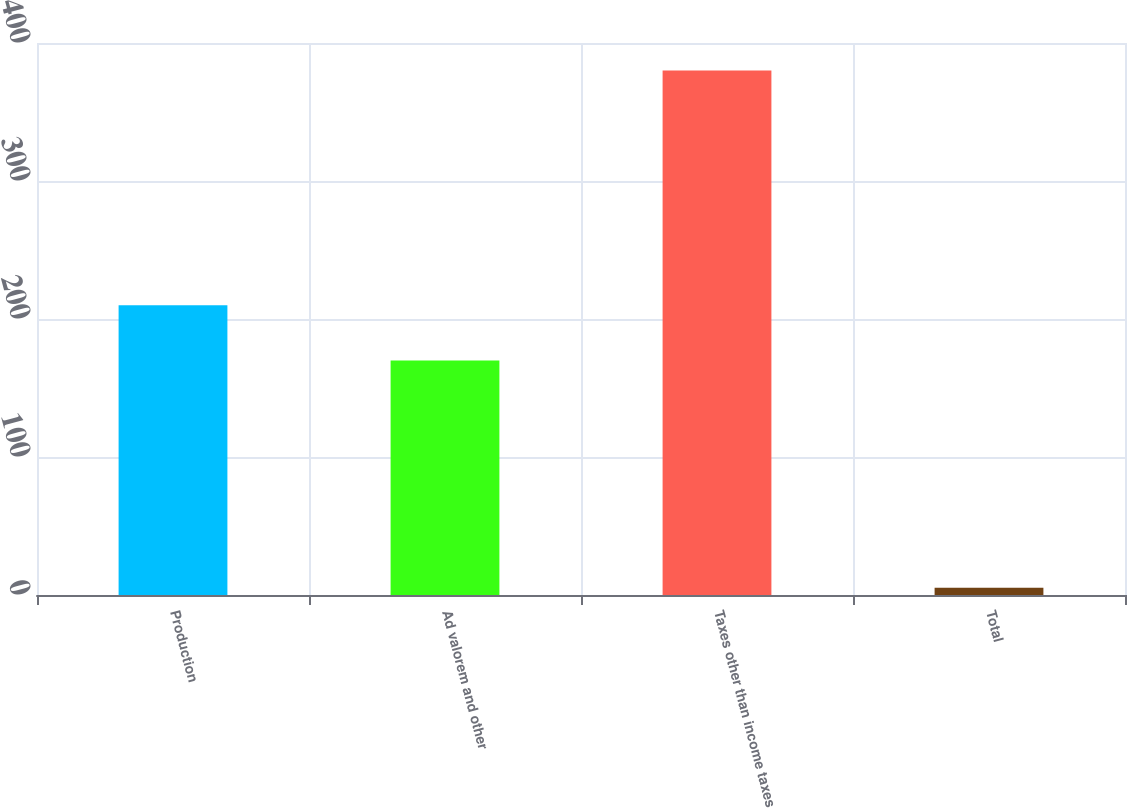Convert chart. <chart><loc_0><loc_0><loc_500><loc_500><bar_chart><fcel>Production<fcel>Ad valorem and other<fcel>Taxes other than income taxes<fcel>Total<nl><fcel>210<fcel>170<fcel>380<fcel>5.24<nl></chart> 